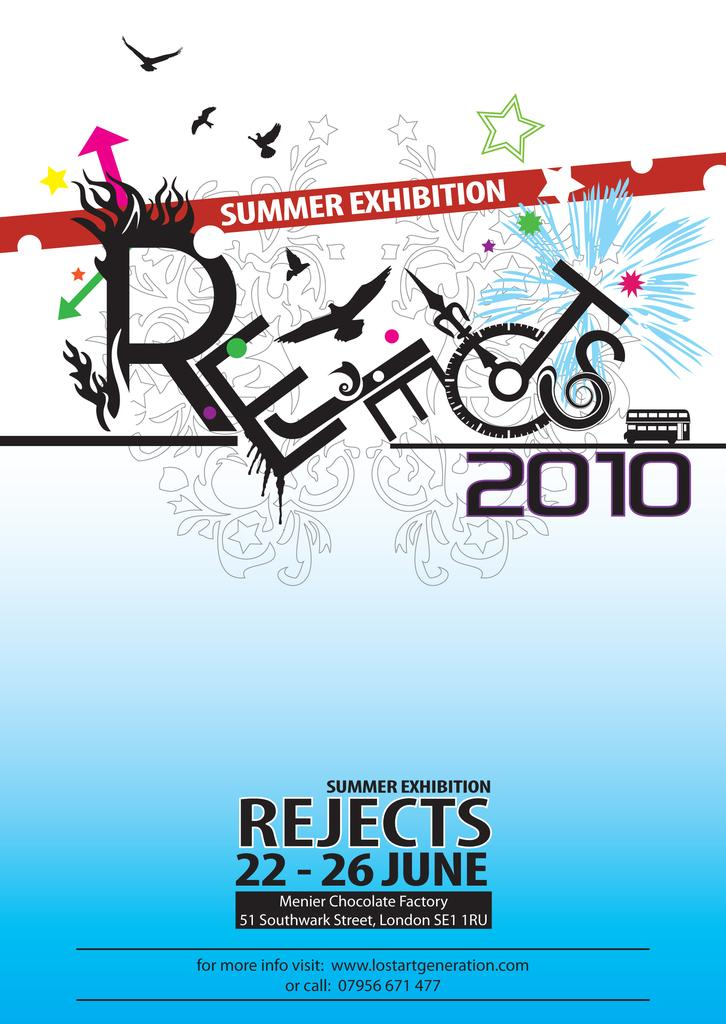<image>
Share a concise interpretation of the image provided. Flyer feauring information about the summer exibition, Rejects 2010. 